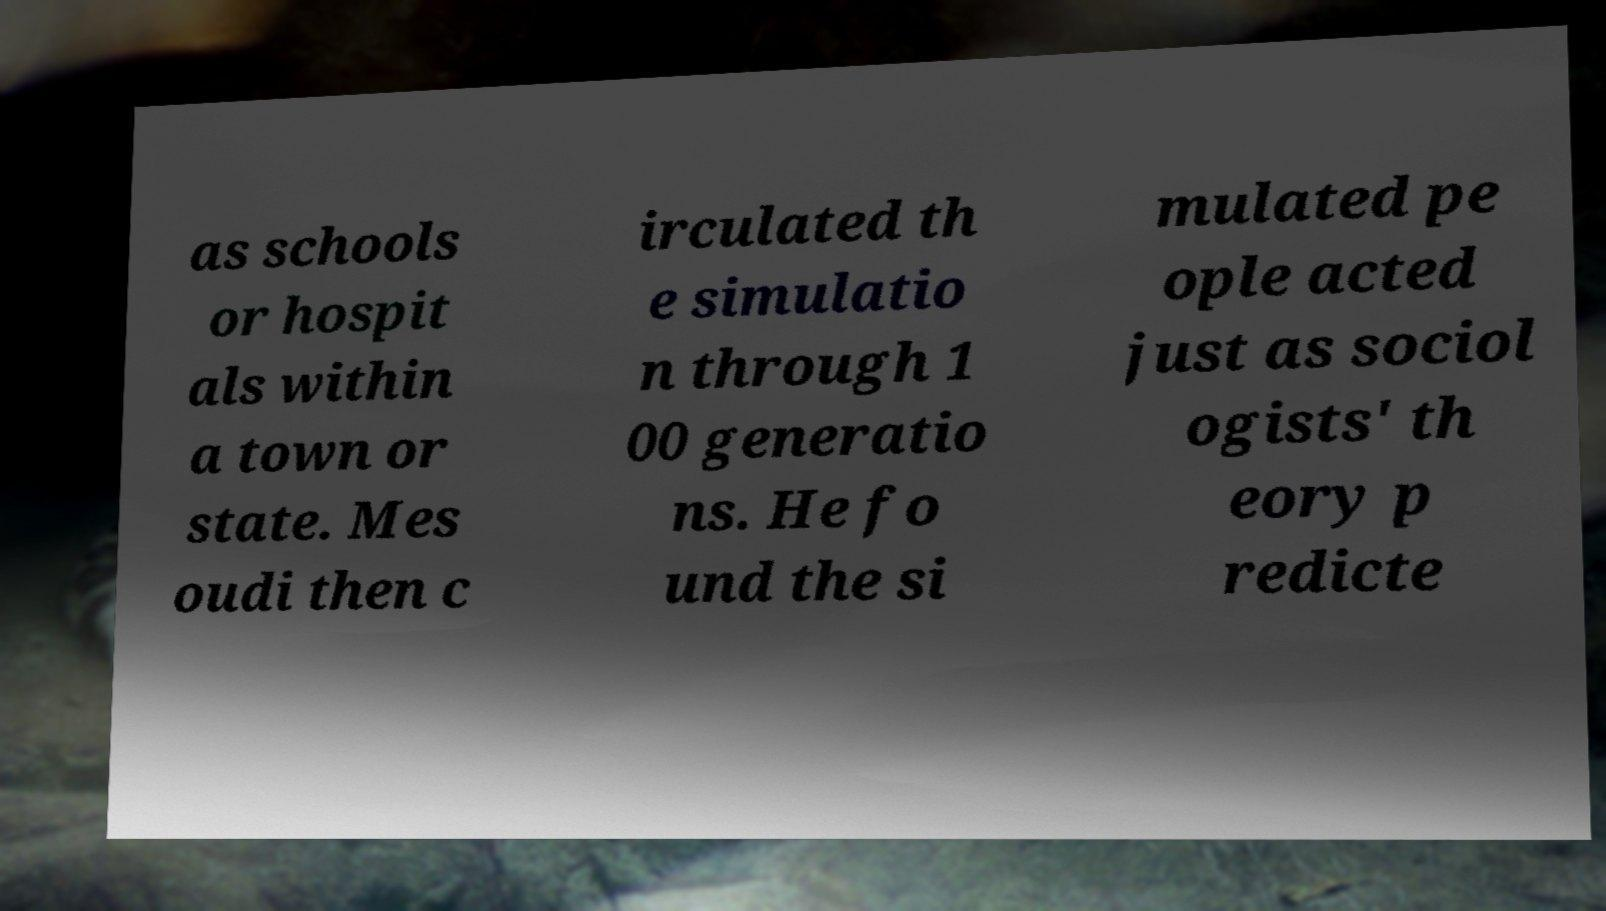Can you read and provide the text displayed in the image?This photo seems to have some interesting text. Can you extract and type it out for me? as schools or hospit als within a town or state. Mes oudi then c irculated th e simulatio n through 1 00 generatio ns. He fo und the si mulated pe ople acted just as sociol ogists' th eory p redicte 